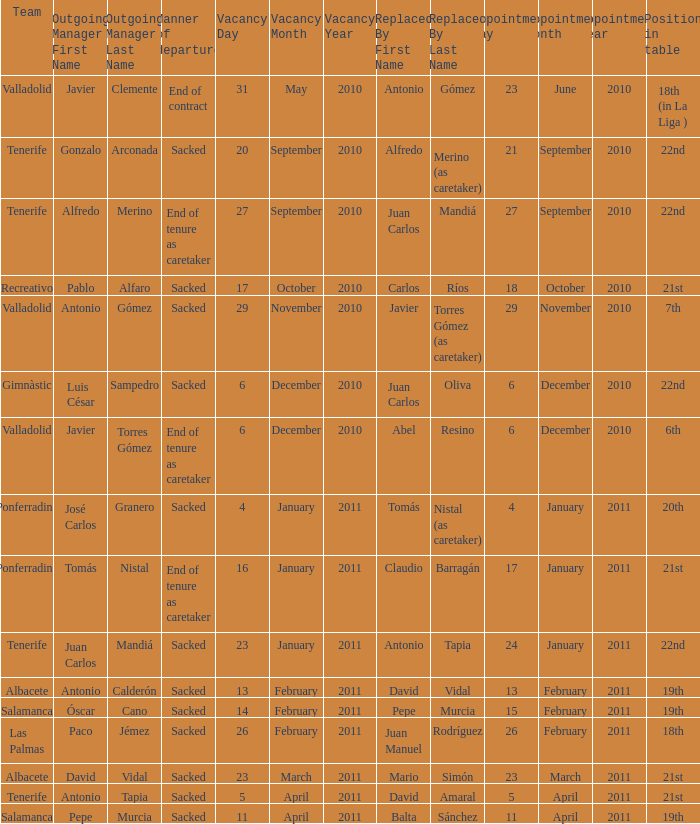How many teams had an outgoing manager of antonio gómez 1.0. 